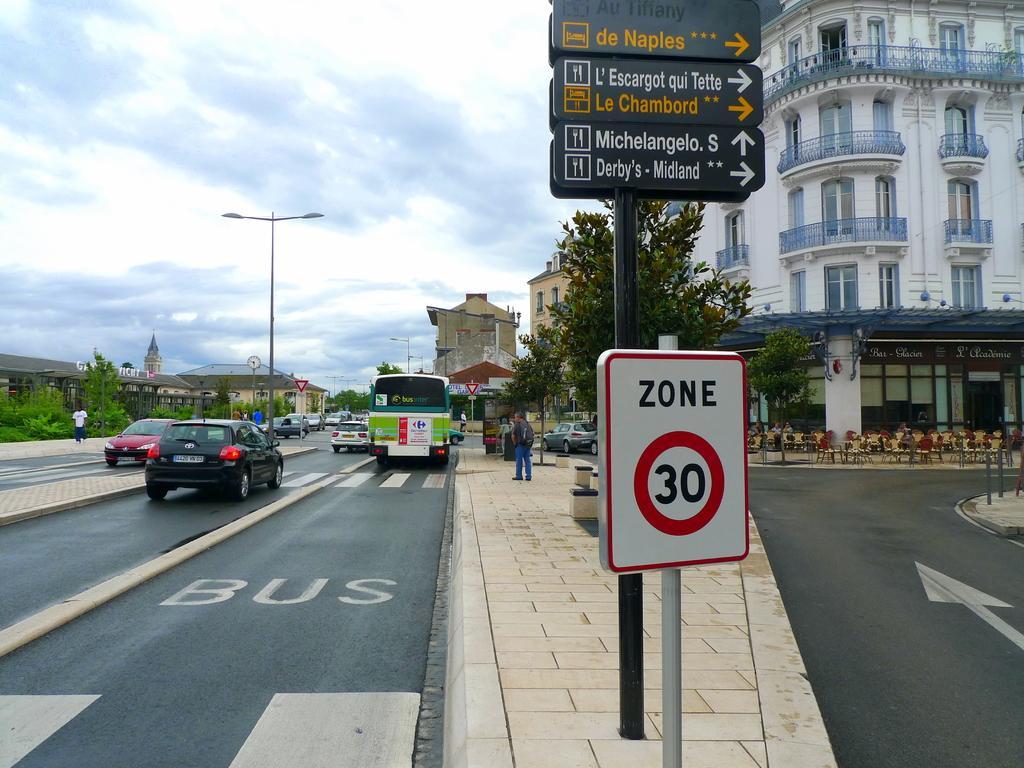In one or two sentences, can you explain what this image depicts? There are sign boards, vehicles on the road, people are present. There are poles, trees and buildings at the back. 